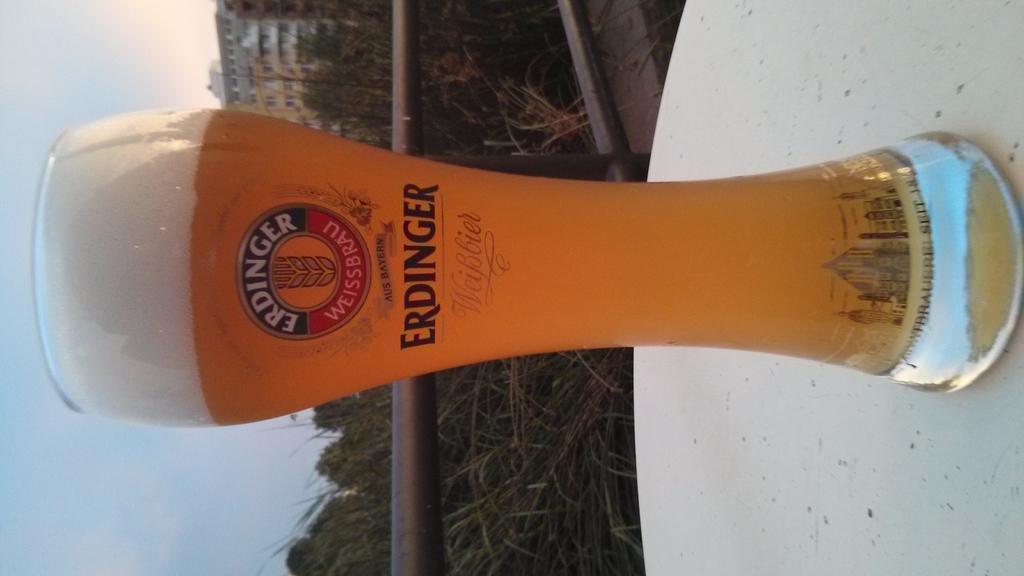In one or two sentences, can you explain what this image depicts? In this image we can see there is a glass of beer on the table. There are trees. There is a building. In the background we can see the sky. 